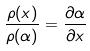<formula> <loc_0><loc_0><loc_500><loc_500>\frac { \rho ( x ) } { \rho ( \alpha ) } = \frac { \partial \alpha } { \partial x }</formula> 